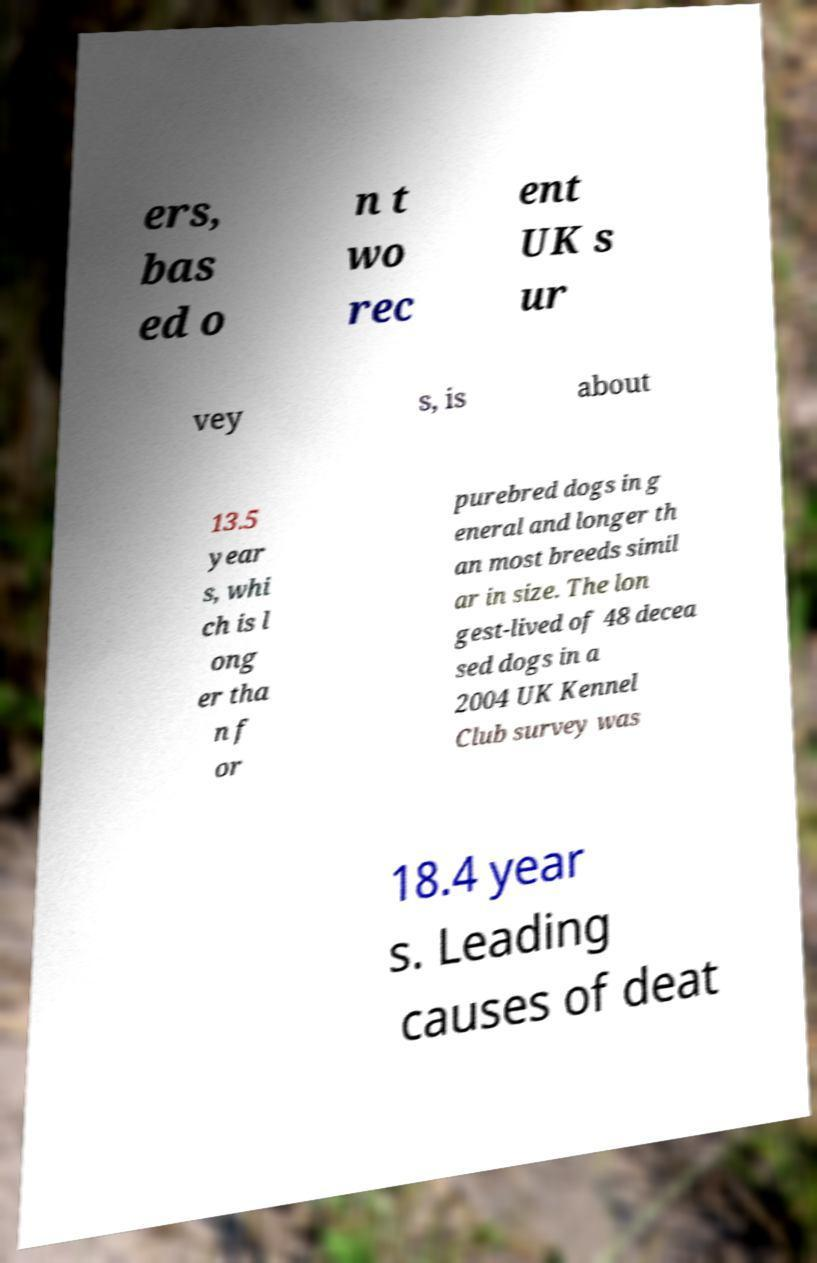Please identify and transcribe the text found in this image. ers, bas ed o n t wo rec ent UK s ur vey s, is about 13.5 year s, whi ch is l ong er tha n f or purebred dogs in g eneral and longer th an most breeds simil ar in size. The lon gest-lived of 48 decea sed dogs in a 2004 UK Kennel Club survey was 18.4 year s. Leading causes of deat 